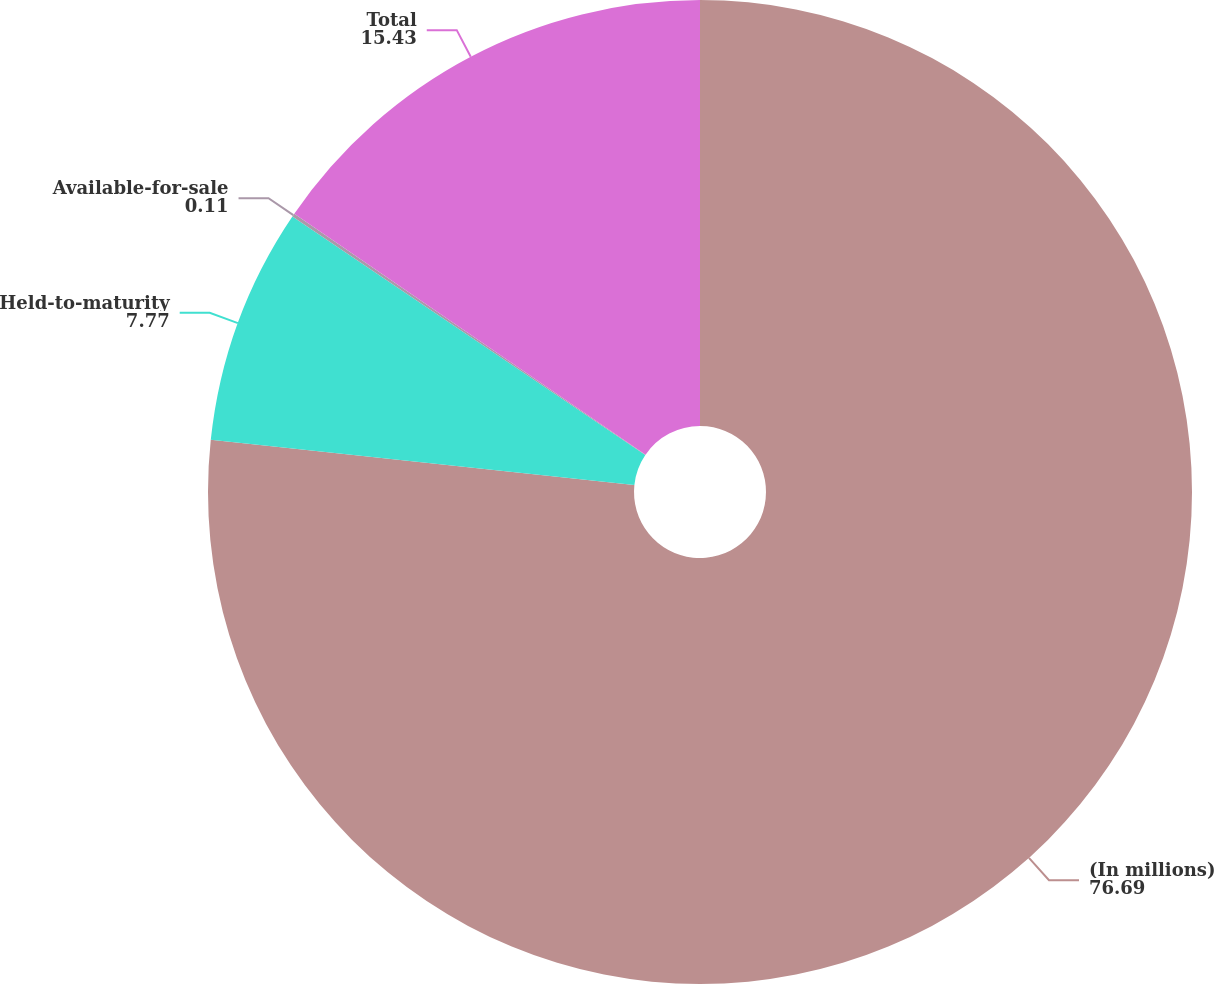Convert chart. <chart><loc_0><loc_0><loc_500><loc_500><pie_chart><fcel>(In millions)<fcel>Held-to-maturity<fcel>Available-for-sale<fcel>Total<nl><fcel>76.69%<fcel>7.77%<fcel>0.11%<fcel>15.43%<nl></chart> 